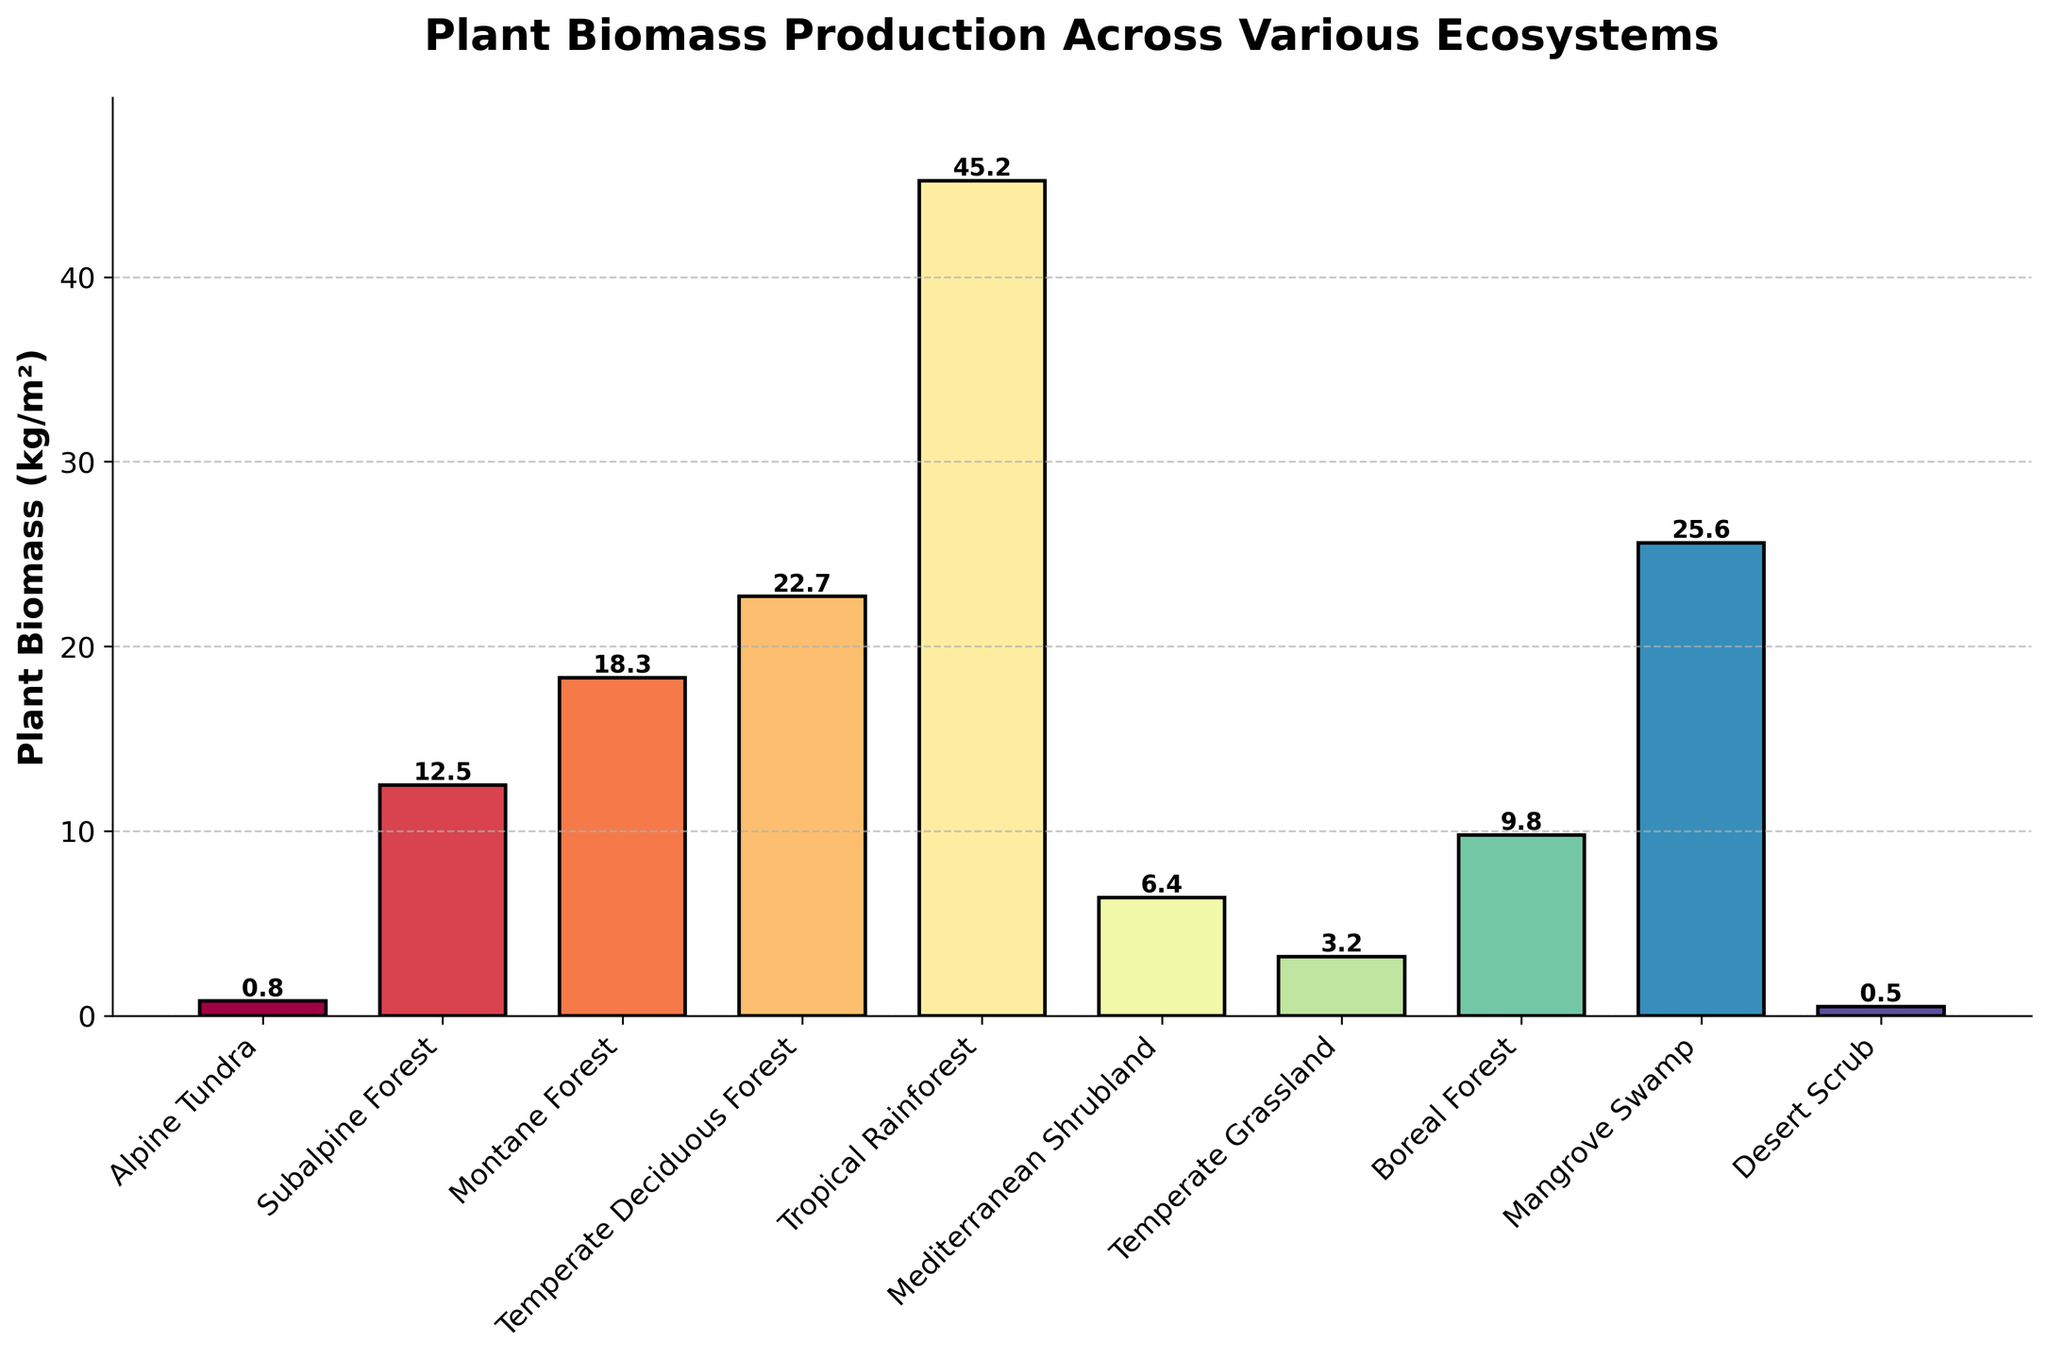Which ecosystem has the highest plant biomass production? The tallest bar in the bar chart represents plant biomass production. The Tropical Rainforest bar is the highest.
Answer: Tropical Rainforest Which ecosystem has the lowest plant biomass production? The shortest bar in the bar chart represents plant biomass production. The Desert Scrub bar is the shortest.
Answer: Desert Scrub Compare the plant biomass production of Mangrove Swamp and Temperate Deciduous Forest. Which one is higher? By comparing the heights of the two bars, Mangrove Swamp's bar is slightly higher than Temperate Deciduous Forest's bar.
Answer: Mangrove Swamp What is the combined plant biomass production of Alpine Tundra and Desert Scrub? The bar heights for Alpine Tundra and Desert Scrub are 0.8 kg/m² and 0.5 kg/m² respectively. Sum them up: 0.8 + 0.5 = 1.3 kg/m².
Answer: 1.3 kg/m² How much greater is the plant biomass production in Tropical Rainforest compared to Mediterranean Shrubland? The heights of the bars for Tropical Rainforest and Mediterranean Shrubland are 45.2 kg/m² and 6.4 kg/m² respectively. Subtract the biomass of Mediterranean Shrubland from Tropical Rainforest: 45.2 - 6.4 = 38.8 kg/m².
Answer: 38.8 kg/m² Which ecosystems have a plant biomass production greater than 20 kg/m², and how many are there? The ecosystems with bars taller than 20 kg/m² are Tropical Rainforest, Temperate Deciduous Forest, and Mangrove Swamp. There are 3 ecosystems.
Answer: Tropical Rainforest, Temperate Deciduous Forest, Mangrove Swamp; 3 ecosystems Calculate the average plant biomass production for the ecosystems with an elevation below 1000 meters (Temperate Deciduous Forest, Tropical Rainforest, Mediterranean Shrubland, Temperate Grassland, Boreal Forest, Mangrove Swamp, Desert Scrub). Adding the biomass for these ecosystems: 22.7 (Temperate Deciduous Forest) + 45.2 (Tropical Rainforest) + 6.4 (Mediterranean Shrubland) + 3.2 (Temperate Grassland) + 9.8 (Boreal Forest) + 25.6 (Mangrove Swamp) + 0.5 (Desert Scrub) = 113.4 kg/m². There are 7 ecosystems: 113.4 / 7 = 16.2 kg/m².
Answer: 16.2 kg/m² Determine the median plant biomass production across all the ecosystems. Order the biomass values: 0.5, 0.8, 3.2, 6.4, 9.8, 12.5, 18.3, 22.7, 25.6, 45.2. The median value is the middle one in this ordered list: (9.8 + 12.5) / 2 = 11.15 kg/m².
Answer: 11.15 kg/m² What is the difference in plant biomass production between Montane Forest and Boreal Forest? The heights of the bars for Montane Forest and Boreal Forest are 18.3 kg/m² and 9.8 kg/m² respectively. Subtract the biomass of Boreal Forest from Montane Forest: 18.3 - 9.8 = 8.5 kg/m².
Answer: 8.5 kg/m² 